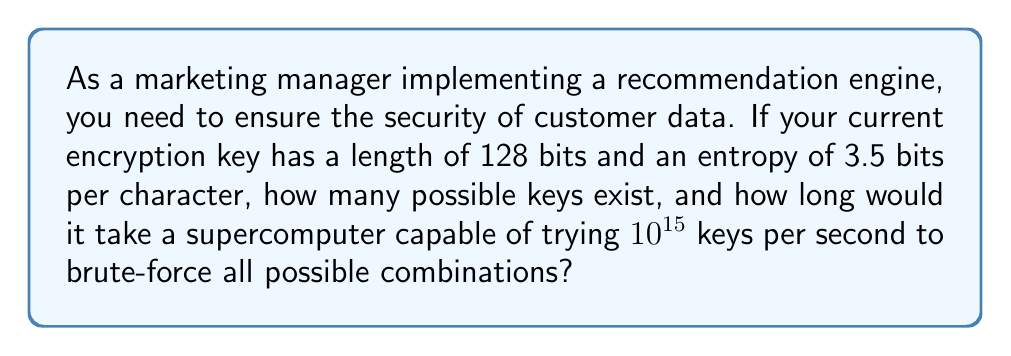Solve this math problem. 1. Calculate the number of possible keys:
   - Number of possible keys = $2^{\text{key length}}$
   - In this case: $2^{128} = 3.4028237 \times 10^{38}$ possible keys

2. Calculate the time needed to brute-force all combinations:
   - Time = $\frac{\text{Number of possible keys}}{\text{Keys tried per second}}$
   - Time = $\frac{3.4028237 \times 10^{38}}{10^{15}}$ seconds
   
3. Convert seconds to years:
   - Seconds in a year = 365.25 days × 24 hours × 60 minutes × 60 seconds = 31,557,600
   - Years = $\frac{3.4028237 \times 10^{38}}{10^{15} \times 31,557,600}$
   - Years ≈ $1.0782 \times 10^{16}$ years

4. The entropy of 3.5 bits per character indicates a relatively strong key, as it suggests a good level of randomness in the key generation process. However, this information is not directly used in the calculation of brute-force time.
Answer: $3.4028237 \times 10^{38}$ possible keys; $1.0782 \times 10^{16}$ years to brute-force 